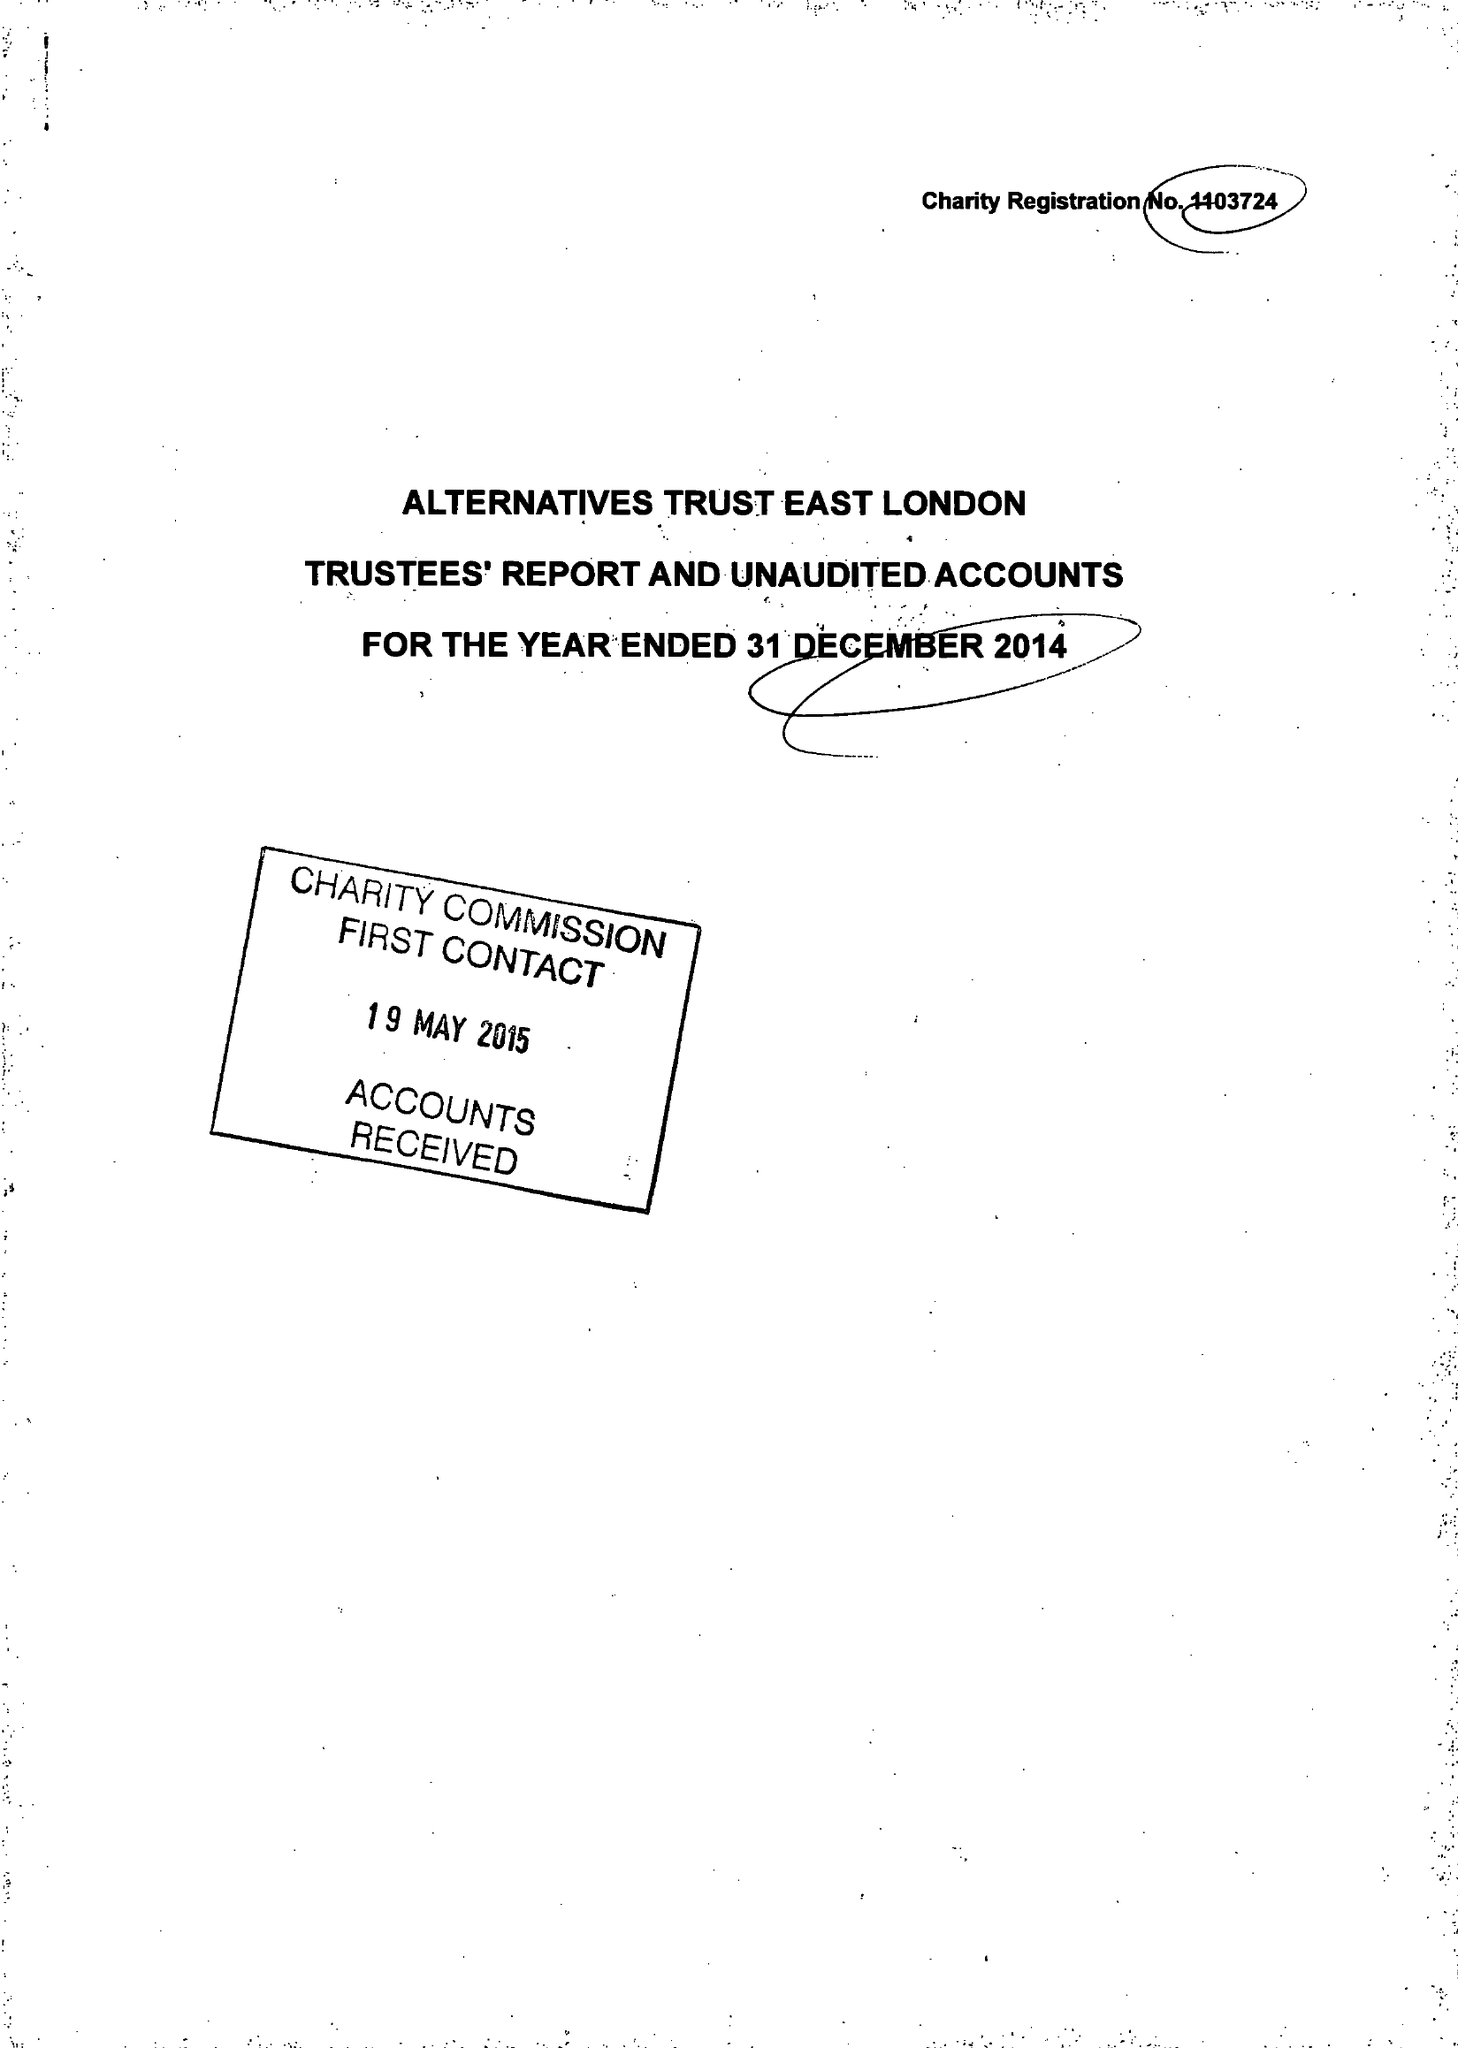What is the value for the address__street_line?
Answer the question using a single word or phrase. 63 ROWNTREE CLIFFORD CLOSE 